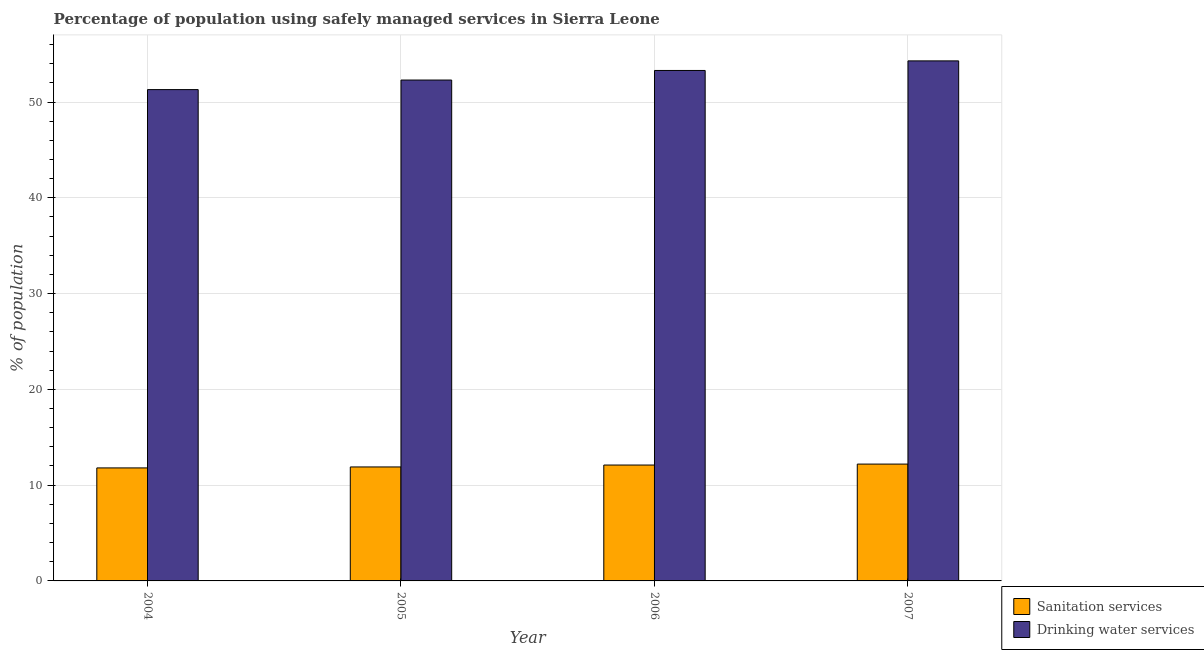How many groups of bars are there?
Offer a very short reply. 4. Are the number of bars on each tick of the X-axis equal?
Your answer should be very brief. Yes. How many bars are there on the 4th tick from the right?
Provide a short and direct response. 2. What is the label of the 1st group of bars from the left?
Keep it short and to the point. 2004. What is the percentage of population who used sanitation services in 2005?
Provide a short and direct response. 11.9. Across all years, what is the maximum percentage of population who used drinking water services?
Your response must be concise. 54.3. Across all years, what is the minimum percentage of population who used drinking water services?
Your answer should be very brief. 51.3. In which year was the percentage of population who used drinking water services minimum?
Make the answer very short. 2004. What is the total percentage of population who used sanitation services in the graph?
Offer a very short reply. 48. What is the difference between the percentage of population who used drinking water services in 2004 and that in 2007?
Your answer should be compact. -3. What is the difference between the percentage of population who used drinking water services in 2006 and the percentage of population who used sanitation services in 2007?
Make the answer very short. -1. What is the average percentage of population who used sanitation services per year?
Provide a short and direct response. 12. What is the ratio of the percentage of population who used drinking water services in 2005 to that in 2006?
Your answer should be compact. 0.98. Is the percentage of population who used drinking water services in 2005 less than that in 2006?
Give a very brief answer. Yes. Is the difference between the percentage of population who used drinking water services in 2005 and 2006 greater than the difference between the percentage of population who used sanitation services in 2005 and 2006?
Your answer should be compact. No. What is the difference between the highest and the second highest percentage of population who used sanitation services?
Your answer should be very brief. 0.1. What is the difference between the highest and the lowest percentage of population who used sanitation services?
Make the answer very short. 0.4. In how many years, is the percentage of population who used drinking water services greater than the average percentage of population who used drinking water services taken over all years?
Your answer should be compact. 2. What does the 1st bar from the left in 2007 represents?
Your response must be concise. Sanitation services. What does the 1st bar from the right in 2005 represents?
Your response must be concise. Drinking water services. Are all the bars in the graph horizontal?
Give a very brief answer. No. How many years are there in the graph?
Ensure brevity in your answer.  4. What is the difference between two consecutive major ticks on the Y-axis?
Offer a very short reply. 10. Are the values on the major ticks of Y-axis written in scientific E-notation?
Ensure brevity in your answer.  No. Does the graph contain any zero values?
Make the answer very short. No. Where does the legend appear in the graph?
Make the answer very short. Bottom right. How many legend labels are there?
Keep it short and to the point. 2. How are the legend labels stacked?
Provide a succinct answer. Vertical. What is the title of the graph?
Offer a terse response. Percentage of population using safely managed services in Sierra Leone. Does "Nitrous oxide" appear as one of the legend labels in the graph?
Your answer should be compact. No. What is the label or title of the Y-axis?
Provide a succinct answer. % of population. What is the % of population of Sanitation services in 2004?
Provide a short and direct response. 11.8. What is the % of population in Drinking water services in 2004?
Ensure brevity in your answer.  51.3. What is the % of population in Drinking water services in 2005?
Ensure brevity in your answer.  52.3. What is the % of population in Sanitation services in 2006?
Keep it short and to the point. 12.1. What is the % of population of Drinking water services in 2006?
Keep it short and to the point. 53.3. What is the % of population of Sanitation services in 2007?
Make the answer very short. 12.2. What is the % of population of Drinking water services in 2007?
Offer a terse response. 54.3. Across all years, what is the maximum % of population in Sanitation services?
Make the answer very short. 12.2. Across all years, what is the maximum % of population of Drinking water services?
Your answer should be very brief. 54.3. Across all years, what is the minimum % of population in Sanitation services?
Ensure brevity in your answer.  11.8. Across all years, what is the minimum % of population of Drinking water services?
Provide a succinct answer. 51.3. What is the total % of population in Drinking water services in the graph?
Make the answer very short. 211.2. What is the difference between the % of population of Drinking water services in 2004 and that in 2005?
Provide a short and direct response. -1. What is the difference between the % of population of Sanitation services in 2004 and that in 2007?
Make the answer very short. -0.4. What is the difference between the % of population in Drinking water services in 2004 and that in 2007?
Offer a terse response. -3. What is the difference between the % of population of Drinking water services in 2005 and that in 2006?
Ensure brevity in your answer.  -1. What is the difference between the % of population in Sanitation services in 2005 and that in 2007?
Your answer should be compact. -0.3. What is the difference between the % of population in Drinking water services in 2005 and that in 2007?
Make the answer very short. -2. What is the difference between the % of population in Drinking water services in 2006 and that in 2007?
Make the answer very short. -1. What is the difference between the % of population in Sanitation services in 2004 and the % of population in Drinking water services in 2005?
Your answer should be very brief. -40.5. What is the difference between the % of population of Sanitation services in 2004 and the % of population of Drinking water services in 2006?
Keep it short and to the point. -41.5. What is the difference between the % of population in Sanitation services in 2004 and the % of population in Drinking water services in 2007?
Your answer should be compact. -42.5. What is the difference between the % of population of Sanitation services in 2005 and the % of population of Drinking water services in 2006?
Your response must be concise. -41.4. What is the difference between the % of population of Sanitation services in 2005 and the % of population of Drinking water services in 2007?
Your response must be concise. -42.4. What is the difference between the % of population in Sanitation services in 2006 and the % of population in Drinking water services in 2007?
Offer a terse response. -42.2. What is the average % of population of Drinking water services per year?
Ensure brevity in your answer.  52.8. In the year 2004, what is the difference between the % of population of Sanitation services and % of population of Drinking water services?
Keep it short and to the point. -39.5. In the year 2005, what is the difference between the % of population of Sanitation services and % of population of Drinking water services?
Give a very brief answer. -40.4. In the year 2006, what is the difference between the % of population of Sanitation services and % of population of Drinking water services?
Make the answer very short. -41.2. In the year 2007, what is the difference between the % of population of Sanitation services and % of population of Drinking water services?
Give a very brief answer. -42.1. What is the ratio of the % of population in Sanitation services in 2004 to that in 2005?
Your response must be concise. 0.99. What is the ratio of the % of population in Drinking water services in 2004 to that in 2005?
Provide a succinct answer. 0.98. What is the ratio of the % of population of Sanitation services in 2004 to that in 2006?
Ensure brevity in your answer.  0.98. What is the ratio of the % of population in Drinking water services in 2004 to that in 2006?
Keep it short and to the point. 0.96. What is the ratio of the % of population of Sanitation services in 2004 to that in 2007?
Offer a very short reply. 0.97. What is the ratio of the % of population of Drinking water services in 2004 to that in 2007?
Provide a succinct answer. 0.94. What is the ratio of the % of population of Sanitation services in 2005 to that in 2006?
Keep it short and to the point. 0.98. What is the ratio of the % of population in Drinking water services in 2005 to that in 2006?
Make the answer very short. 0.98. What is the ratio of the % of population of Sanitation services in 2005 to that in 2007?
Offer a terse response. 0.98. What is the ratio of the % of population in Drinking water services in 2005 to that in 2007?
Offer a very short reply. 0.96. What is the ratio of the % of population in Sanitation services in 2006 to that in 2007?
Provide a succinct answer. 0.99. What is the ratio of the % of population in Drinking water services in 2006 to that in 2007?
Your answer should be very brief. 0.98. 